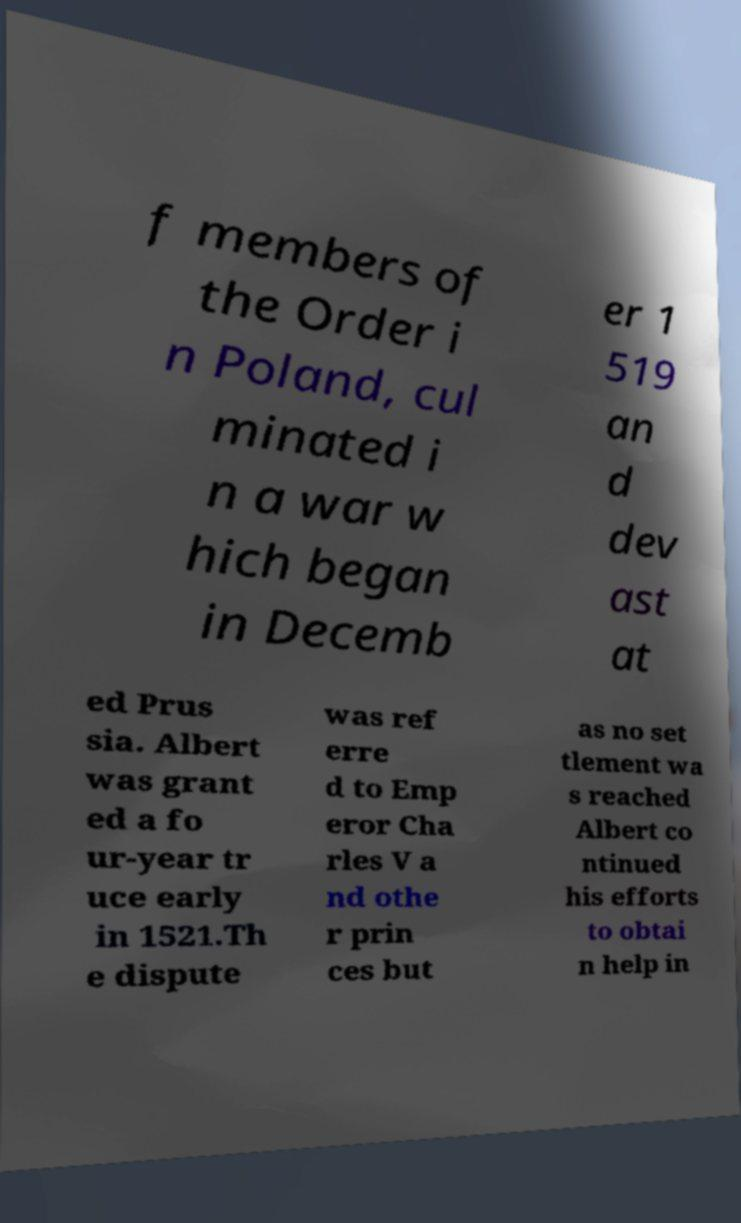There's text embedded in this image that I need extracted. Can you transcribe it verbatim? f members of the Order i n Poland, cul minated i n a war w hich began in Decemb er 1 519 an d dev ast at ed Prus sia. Albert was grant ed a fo ur-year tr uce early in 1521.Th e dispute was ref erre d to Emp eror Cha rles V a nd othe r prin ces but as no set tlement wa s reached Albert co ntinued his efforts to obtai n help in 